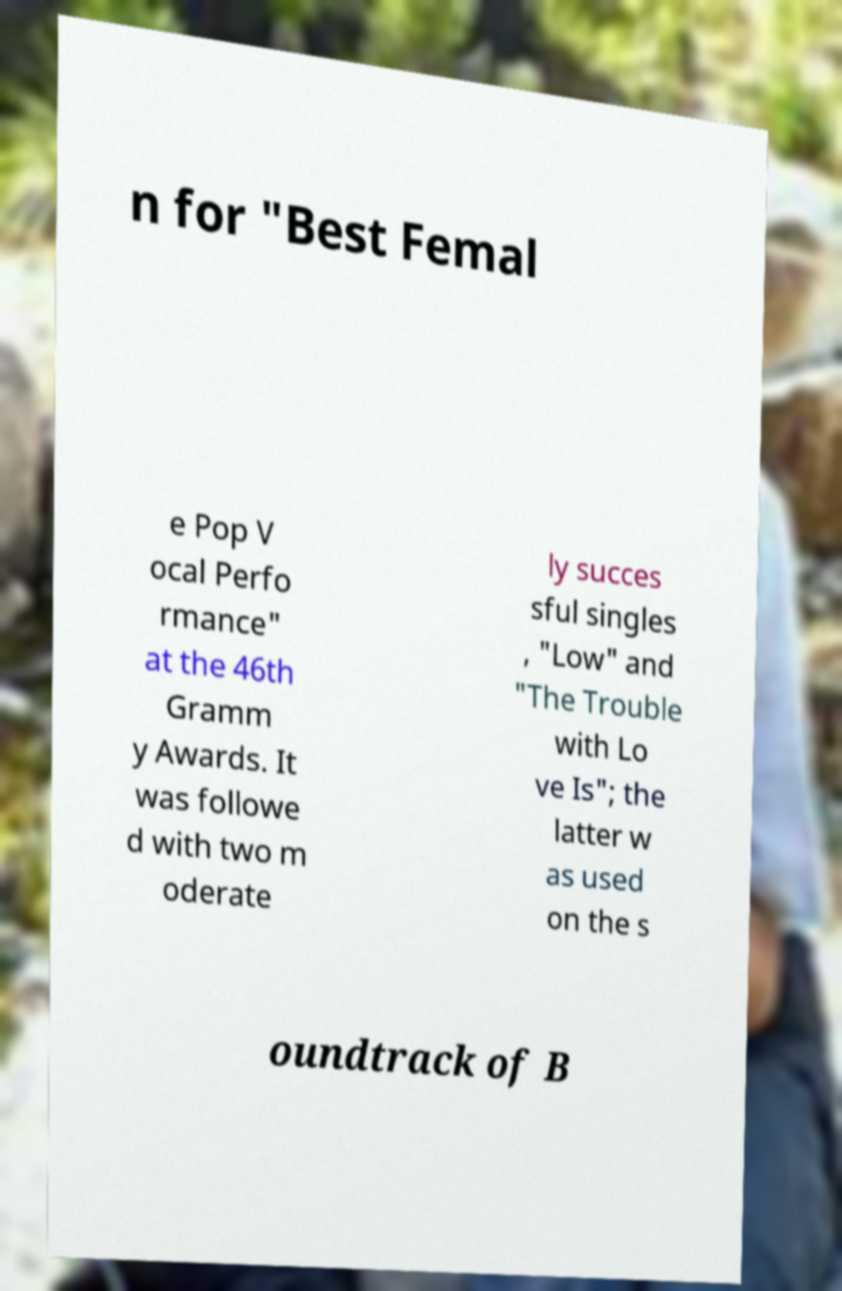Could you assist in decoding the text presented in this image and type it out clearly? n for "Best Femal e Pop V ocal Perfo rmance" at the 46th Gramm y Awards. It was followe d with two m oderate ly succes sful singles , "Low" and "The Trouble with Lo ve Is"; the latter w as used on the s oundtrack of B 